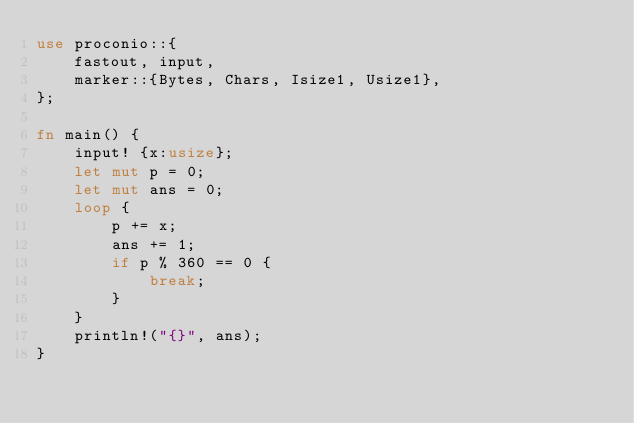<code> <loc_0><loc_0><loc_500><loc_500><_Rust_>use proconio::{
    fastout, input,
    marker::{Bytes, Chars, Isize1, Usize1},
};

fn main() {
    input! {x:usize};
    let mut p = 0;
    let mut ans = 0;
    loop {
        p += x;
        ans += 1;
        if p % 360 == 0 {
            break;
        }
    }
    println!("{}", ans);
}
</code> 